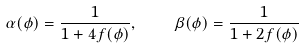Convert formula to latex. <formula><loc_0><loc_0><loc_500><loc_500>\alpha ( \phi ) = { \frac { 1 } { 1 + 4 f ( \phi ) } } , \quad \beta ( \phi ) = { \frac { 1 } { 1 + 2 f ( \phi ) } }</formula> 